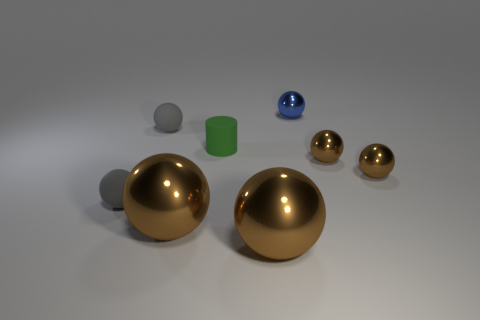Are there any other things that have the same shape as the green rubber thing?
Offer a very short reply. No. How many brown objects are either small matte objects or shiny objects?
Your answer should be very brief. 4. What material is the large sphere that is to the left of the cylinder?
Provide a succinct answer. Metal. There is a large brown thing that is to the right of the green thing; what number of gray matte objects are right of it?
Offer a terse response. 0. What number of large brown things have the same shape as the tiny blue metal thing?
Provide a succinct answer. 2. What number of green metal objects are there?
Make the answer very short. 0. There is a rubber thing that is in front of the small green matte cylinder; what color is it?
Offer a very short reply. Gray. What is the color of the small rubber ball that is behind the gray object that is in front of the green object?
Provide a short and direct response. Gray. The rubber cylinder that is the same size as the blue object is what color?
Your answer should be very brief. Green. What number of metal objects are on the left side of the tiny blue metallic sphere and right of the blue shiny thing?
Provide a short and direct response. 0. 